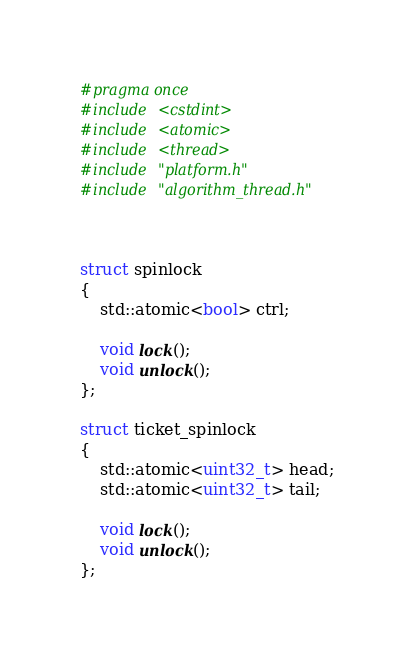<code> <loc_0><loc_0><loc_500><loc_500><_C_>#pragma once
#include <cstdint>
#include <atomic>
#include <thread>
#include "platform.h"
#include "algorithm_thread.h"



struct spinlock
{
	std::atomic<bool> ctrl;

	void lock();
	void unlock();
};

struct ticket_spinlock
{
	std::atomic<uint32_t> head;
	std::atomic<uint32_t> tail;

	void lock();
	void unlock();
};</code> 